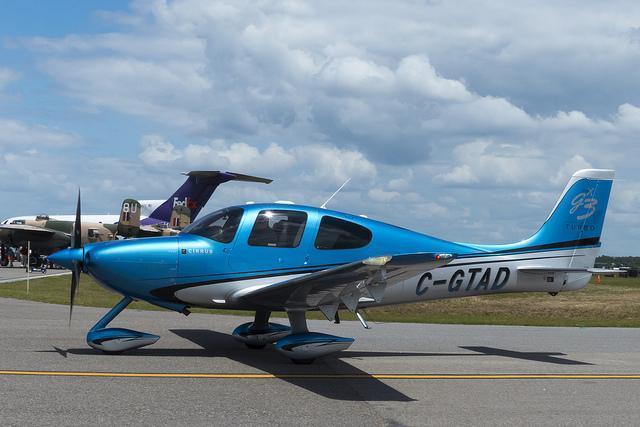How many airplanes can you see?
Give a very brief answer. 2. How many cats have a banana in their paws?
Give a very brief answer. 0. 